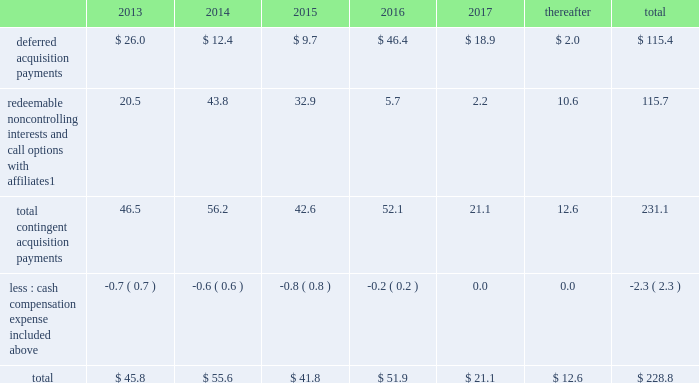Notes to consolidated financial statements 2013 ( continued ) ( amounts in millions , except per share amounts ) guarantees we have guaranteed certain obligations of our subsidiaries relating principally to operating leases and credit facilities of certain subsidiaries .
The amount of parent company guarantees on lease obligations was $ 410.3 and $ 385.1 as of december 31 , 2012 and 2011 , respectively , and the amount of parent company guarantees primarily relating to credit facilities was $ 283.4 and $ 327.5 as of december 31 , 2012 and 2011 , respectively .
In the event of non-payment by the applicable subsidiary of the obligations covered by a guarantee , we would be obligated to pay the amounts covered by that guarantee .
As of december 31 , 2012 , there were no material assets pledged as security for such parent company guarantees .
Contingent acquisition obligations the table details the estimated future contingent acquisition obligations payable in cash as of december 31 .
1 we have entered into certain acquisitions that contain both redeemable noncontrolling interests and call options with similar terms and conditions .
We have certain redeemable noncontrolling interests that are exercisable at the discretion of the noncontrolling equity owners as of december 31 , 2012 .
These estimated payments of $ 16.4 are included within the total payments expected to be made in 2013 , and will continue to be carried forward into 2014 or beyond until exercised or expired .
Redeemable noncontrolling interests are included in the table at current exercise price payable in cash , not at applicable redemption value in accordance with the authoritative guidance for classification and measurement of redeemable securities .
The estimated amounts listed would be paid in the event of exercise at the earliest exercise date .
See note 6 for further information relating to the payment structure of our acquisitions .
All payments are contingent upon achieving projected operating performance targets and satisfying other conditions specified in the related agreements and are subject to revisions as the earn-out periods progress .
Legal matters we are involved in various legal proceedings , and subject to investigations , inspections , audits , inquiries and similar actions by governmental authorities , arising in the normal course of business .
We evaluate all cases each reporting period and record liabilities for losses from legal proceedings when we determine that it is probable that the outcome in a legal proceeding will be unfavorable and the amount , or potential range , of loss can be reasonably estimated .
In certain cases , we cannot reasonably estimate the potential loss because , for example , the litigation is in its early stages .
While any outcome related to litigation or such governmental proceedings in which we are involved cannot be predicted with certainty , management believes that the outcome of these matters , individually and in the aggregate , will not have a material adverse effect on our financial condition , results of operations or cash flows .
Note 15 : recent accounting standards impairment of indefinite-lived intangible assets in july 2012 , the financial accounting standards board ( 201cfasb 201d ) issued amended guidance to simplify impairment testing of indefinite-lived intangible assets other than goodwill .
The amended guidance permits an entity to first assess qualitative factors to determine whether it is 201cmore likely than not 201d that the indefinite-lived intangible asset is impaired .
If , after assessing qualitative factors , an entity concludes that it is not 201cmore likely than not 201d that the indefinite-lived intangible .
In 2013 what was the percent of future contingent acquisition obligations payable in cash for deferred acquisition payments? 
Computations: (26.0 / 45.8)
Answer: 0.56769. 